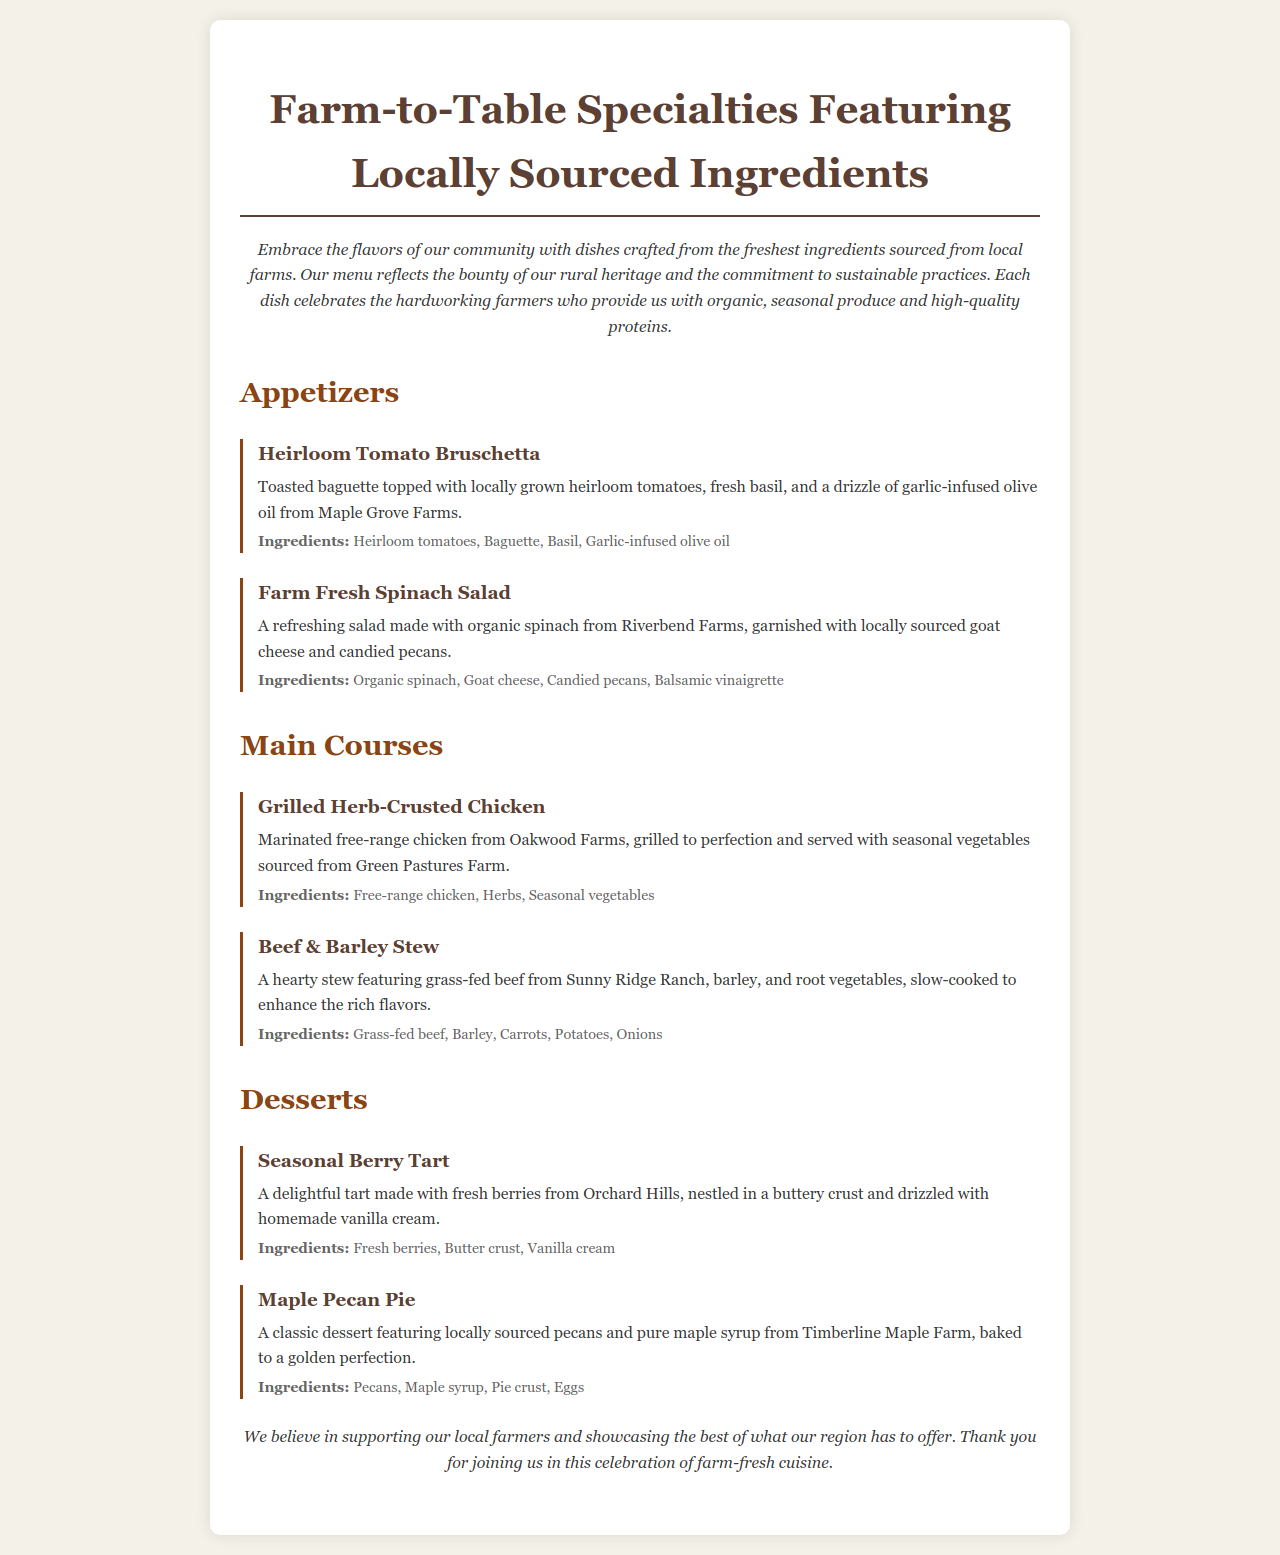What is the title of the menu? The title is prominently displayed at the top of the document and reads "Farm-to-Table Specialties Featuring Locally Sourced Ingredients."
Answer: Farm-to-Table Specialties Featuring Locally Sourced Ingredients What farm is the goat cheese sourced from? The menu states that the goat cheese is sourced from a local farm mentioned in the description of the farm fresh spinach salad.
Answer: Local farm What ingredients are in the heirloom tomato bruschetta? The details in the dish description list the specific ingredients used in heirloom tomato bruschetta, which include heirloom tomatoes, baguette, basil, and garlic-infused olive oil.
Answer: Heirloom tomatoes, Baguette, Basil, Garlic-infused olive oil How many appetizers are listed on the menu? By counting the appetizers section, we see that there are two appetizers listed in the document.
Answer: 2 What type of chicken is used in the grilled herb-crusted chicken dish? The menu specifies that the chicken is free-range, indicating its sourcing method and quality.
Answer: Free-range What kind of dessert features fresh berries? The dessert section mentions a specific dessert that highlights fresh berries as a primary ingredient.
Answer: Seasonal Berry Tart What is the primary protein in the beef & barley stew? The dish description identifies the main protein component used in the beef & barley stew, which is clearly stated.
Answer: Grass-fed beef What do all dishes on the menu emphasize? The introduction highlights a key focus of the menu that applies to all dishes, central to the theme of the restaurant.
Answer: Locally sourced ingredients 